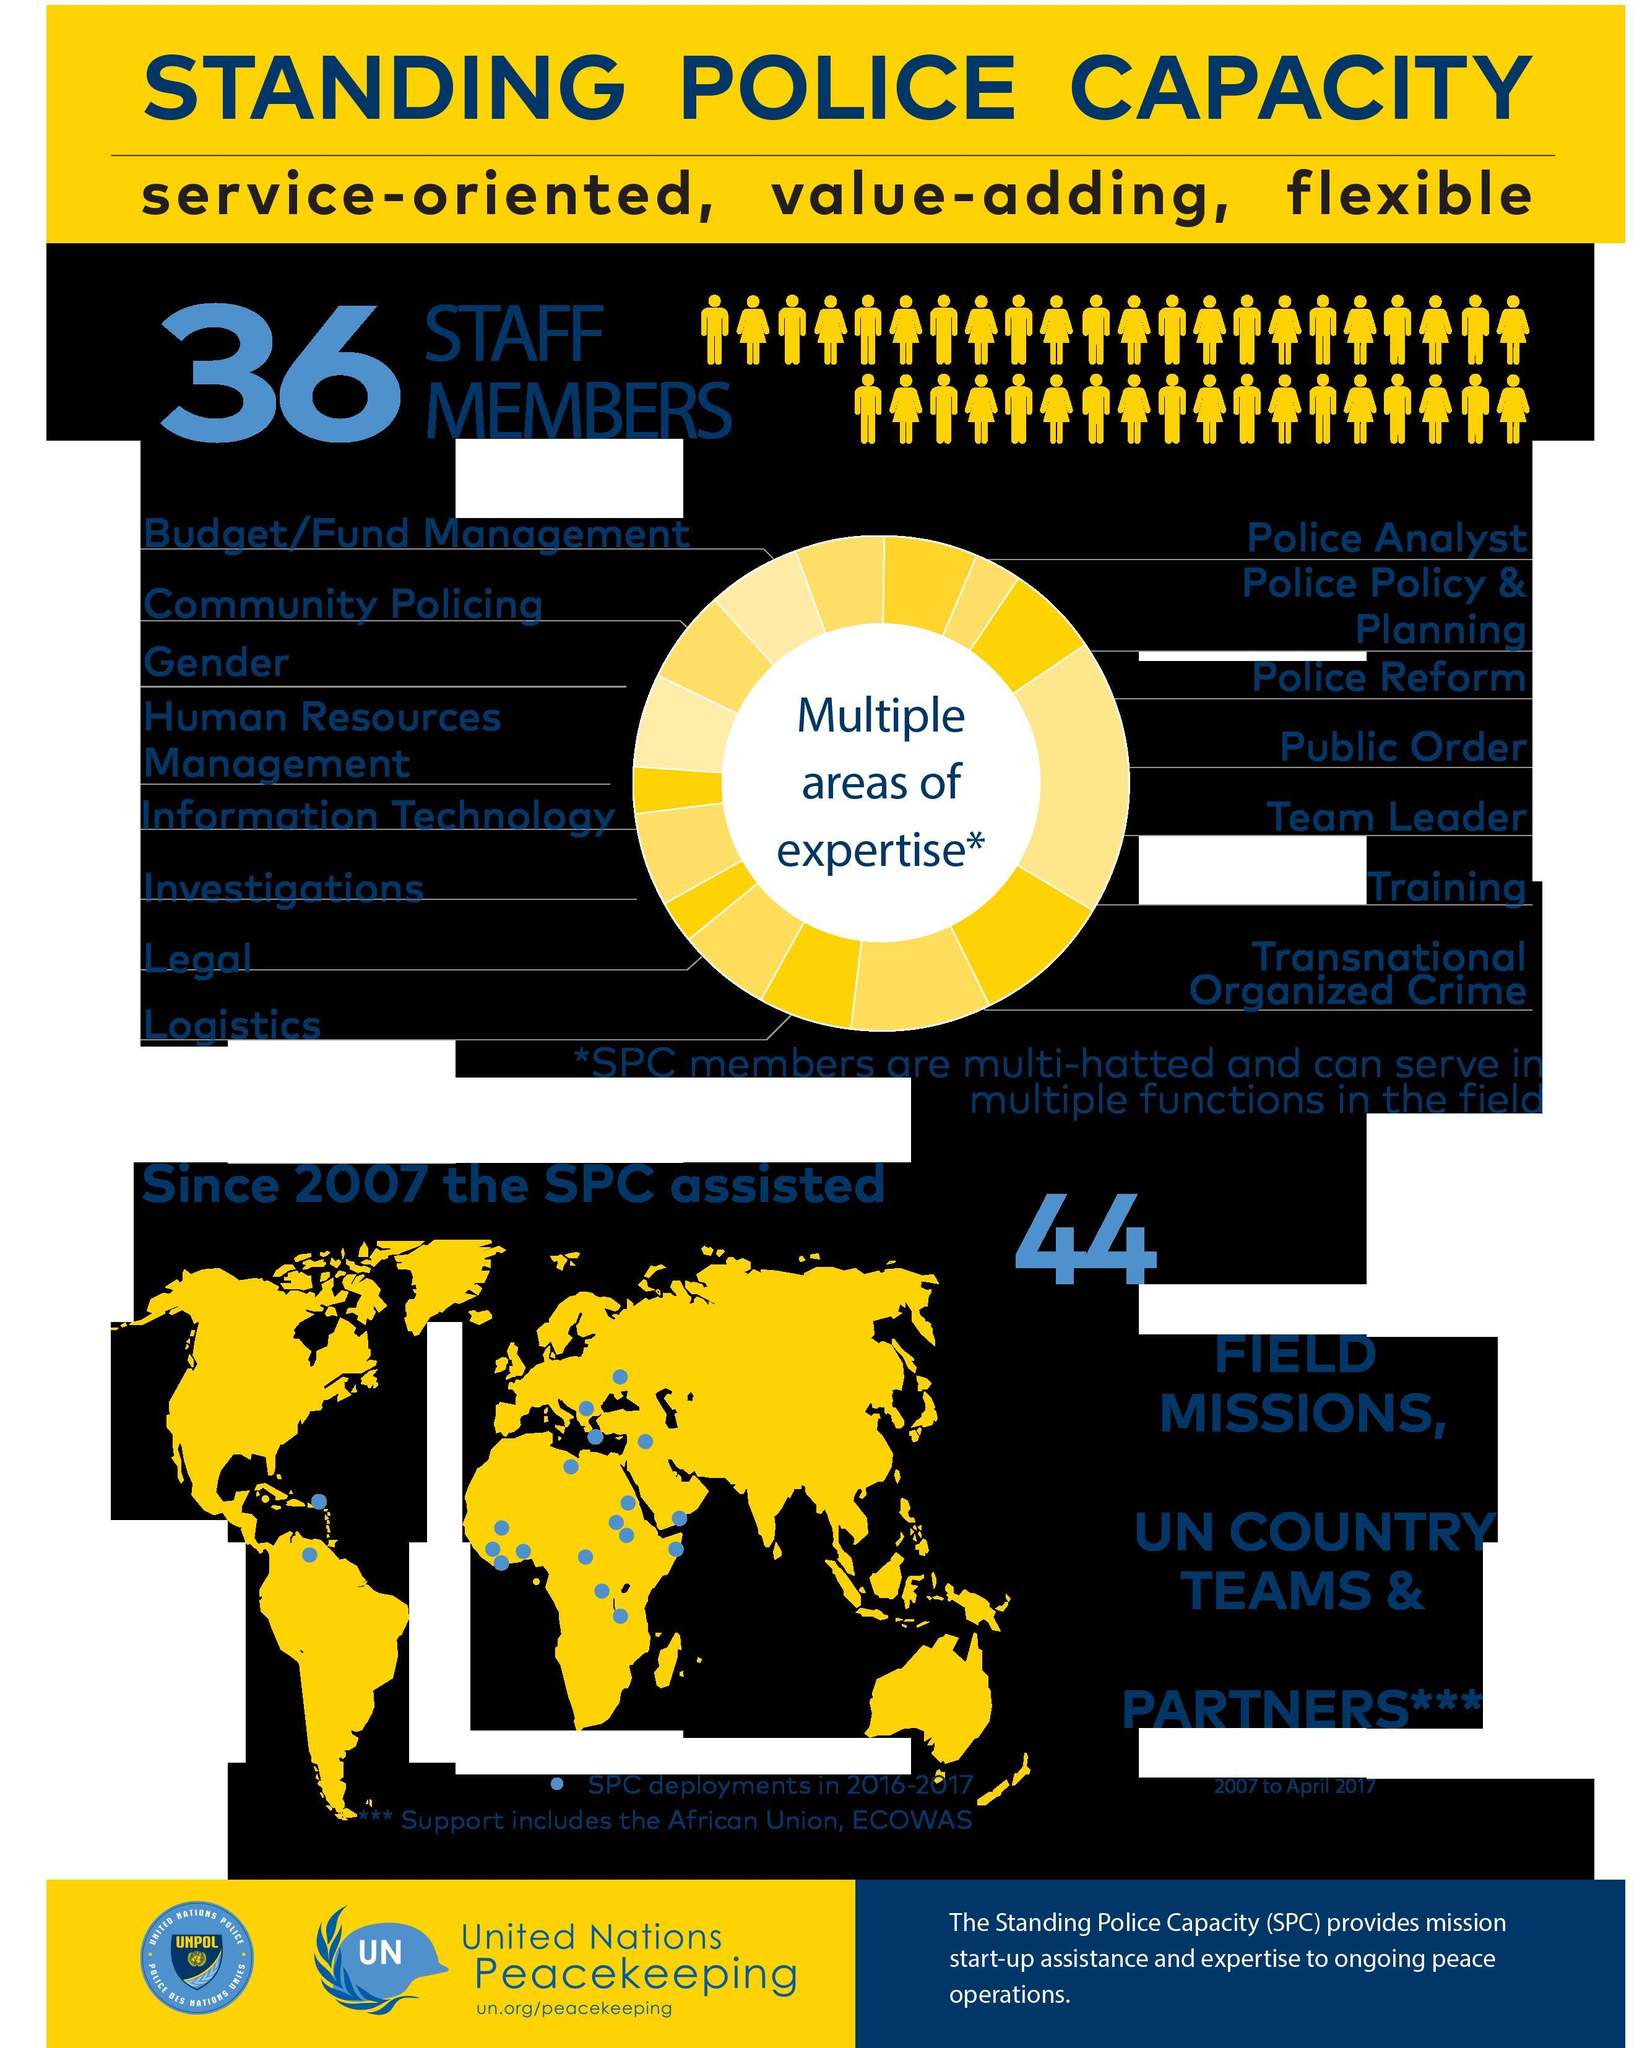What color represents the continents in the infographic, blue, black or yellow?
Answer the question with a short phrase. yellow Which continent did not have an SPC deployment in 2016-2017 according to the map in the infographic? Australia 